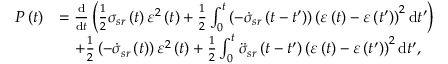Convert formula to latex. <formula><loc_0><loc_0><loc_500><loc_500>\begin{array} { r l } { P \left ( t \right ) } & { = \frac { d } { d t } \left ( \frac { 1 } { 2 } \sigma _ { s r } \left ( t \right ) \varepsilon ^ { 2 } \left ( t \right ) + \frac { 1 } { 2 } \int _ { 0 } ^ { t } \left ( - \dot { \sigma } _ { s r } \left ( t - t ^ { \prime } \right ) \right ) \left ( \varepsilon \left ( t \right ) - \varepsilon \left ( t ^ { \prime } \right ) \right ) ^ { 2 } d t ^ { \prime } \right ) } \\ & { \quad + \frac { 1 } { 2 } \left ( - \dot { \sigma } _ { s r } \left ( t \right ) \right ) \varepsilon ^ { 2 } \left ( t \right ) + \frac { 1 } { 2 } \int _ { 0 } ^ { t } \ddot { \sigma } _ { s r } \left ( t - t ^ { \prime } \right ) \left ( \varepsilon \left ( t \right ) - \varepsilon \left ( t ^ { \prime } \right ) \right ) ^ { 2 } d t ^ { \prime } , } \end{array}</formula> 